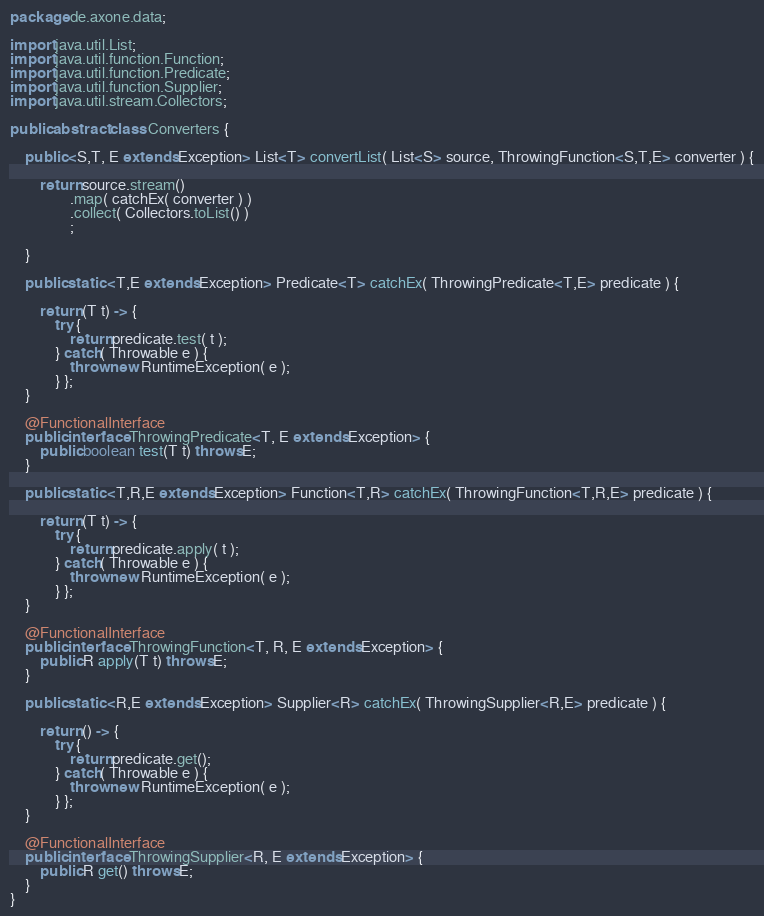Convert code to text. <code><loc_0><loc_0><loc_500><loc_500><_Java_>package de.axone.data;

import java.util.List;
import java.util.function.Function;
import java.util.function.Predicate;
import java.util.function.Supplier;
import java.util.stream.Collectors;

public abstract class Converters {
	
	public <S,T, E extends Exception> List<T> convertList( List<S> source, ThrowingFunction<S,T,E> converter ) {
		
		return source.stream()
				.map( catchEx( converter ) )
				.collect( Collectors.toList() )
				;
		
	}

	public static <T,E extends Exception> Predicate<T> catchEx( ThrowingPredicate<T,E> predicate ) {
		
		return (T t) -> {
			try {
				return predicate.test( t );
			} catch( Throwable e ) {
				throw new RuntimeException( e );
			} };
	}
	
	@FunctionalInterface
	public interface ThrowingPredicate<T, E extends Exception> {
	    public boolean test(T t) throws E;
	}

	public static <T,R,E extends Exception> Function<T,R> catchEx( ThrowingFunction<T,R,E> predicate ) {
		
		return (T t) -> {
			try {
				return predicate.apply( t );
			} catch( Throwable e ) {
				throw new RuntimeException( e );
			} };
	}
	
	@FunctionalInterface
	public interface ThrowingFunction<T, R, E extends Exception> {
	    public R apply(T t) throws E;
	}

	public static <R,E extends Exception> Supplier<R> catchEx( ThrowingSupplier<R,E> predicate ) {
		
		return () -> {
			try {
				return predicate.get();
			} catch( Throwable e ) {
				throw new RuntimeException( e );
			} };
	}
	
	@FunctionalInterface
	public interface ThrowingSupplier<R, E extends Exception> {
	    public R get() throws E;
	}
}
</code> 